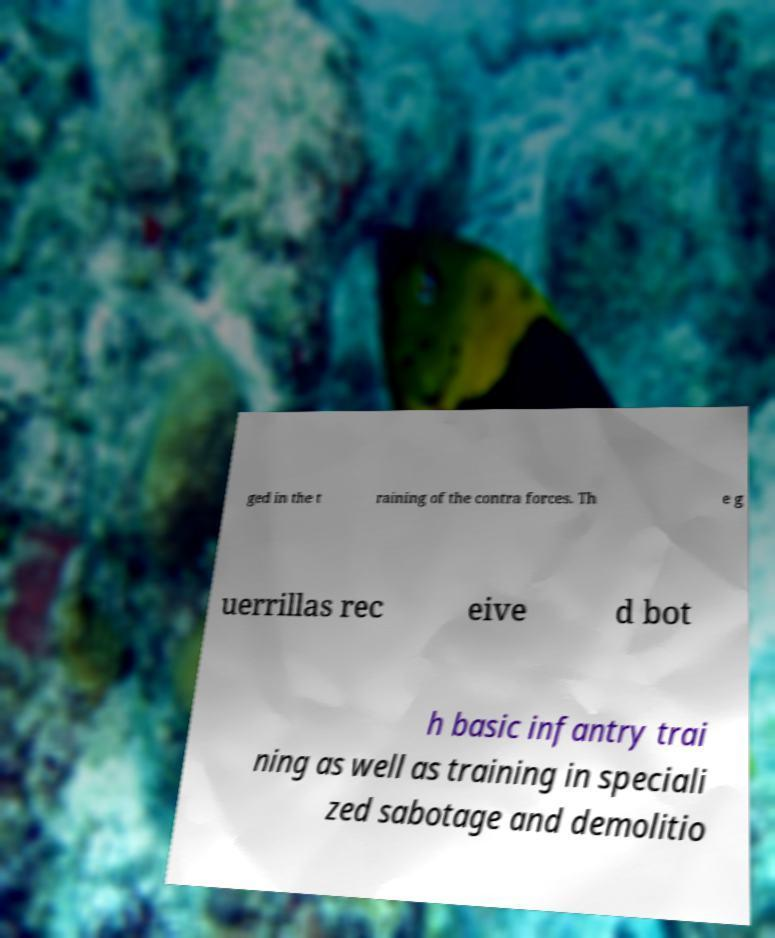Can you read and provide the text displayed in the image?This photo seems to have some interesting text. Can you extract and type it out for me? ged in the t raining of the contra forces. Th e g uerrillas rec eive d bot h basic infantry trai ning as well as training in speciali zed sabotage and demolitio 